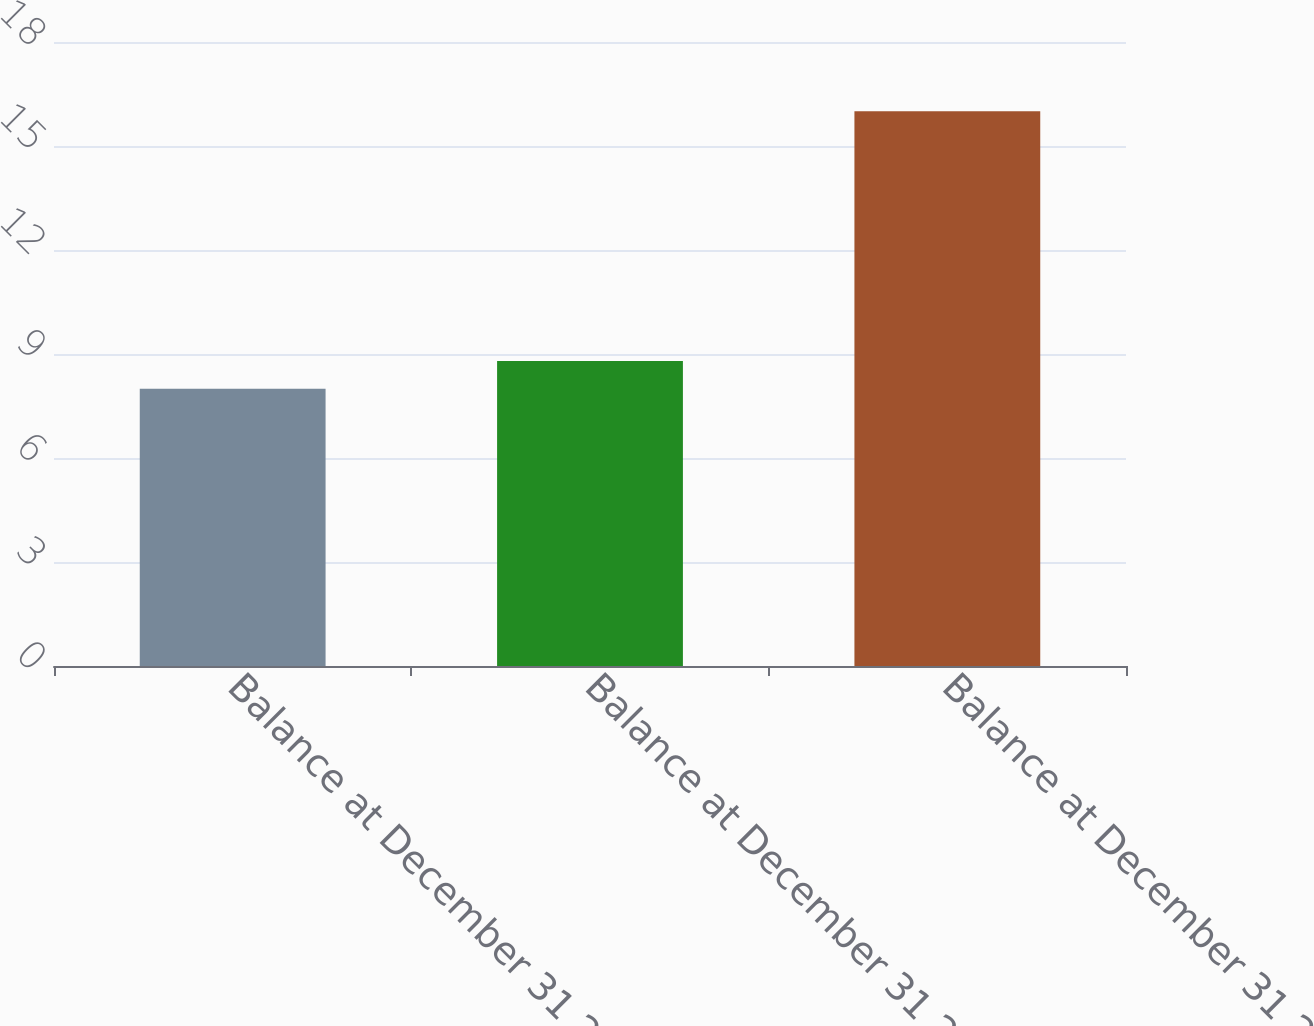Convert chart to OTSL. <chart><loc_0><loc_0><loc_500><loc_500><bar_chart><fcel>Balance at December 31 2014<fcel>Balance at December 31 2015<fcel>Balance at December 31 2016<nl><fcel>8<fcel>8.8<fcel>16<nl></chart> 